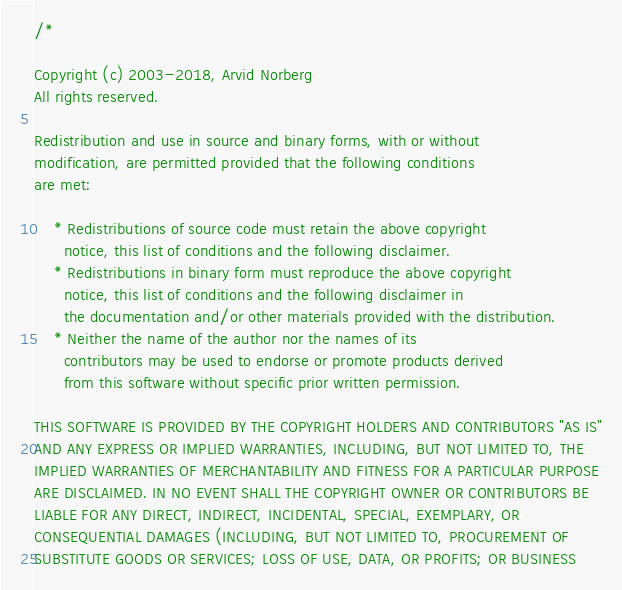<code> <loc_0><loc_0><loc_500><loc_500><_C++_>/*

Copyright (c) 2003-2018, Arvid Norberg
All rights reserved.

Redistribution and use in source and binary forms, with or without
modification, are permitted provided that the following conditions
are met:

    * Redistributions of source code must retain the above copyright
      notice, this list of conditions and the following disclaimer.
    * Redistributions in binary form must reproduce the above copyright
      notice, this list of conditions and the following disclaimer in
      the documentation and/or other materials provided with the distribution.
    * Neither the name of the author nor the names of its
      contributors may be used to endorse or promote products derived
      from this software without specific prior written permission.

THIS SOFTWARE IS PROVIDED BY THE COPYRIGHT HOLDERS AND CONTRIBUTORS "AS IS"
AND ANY EXPRESS OR IMPLIED WARRANTIES, INCLUDING, BUT NOT LIMITED TO, THE
IMPLIED WARRANTIES OF MERCHANTABILITY AND FITNESS FOR A PARTICULAR PURPOSE
ARE DISCLAIMED. IN NO EVENT SHALL THE COPYRIGHT OWNER OR CONTRIBUTORS BE
LIABLE FOR ANY DIRECT, INDIRECT, INCIDENTAL, SPECIAL, EXEMPLARY, OR
CONSEQUENTIAL DAMAGES (INCLUDING, BUT NOT LIMITED TO, PROCUREMENT OF
SUBSTITUTE GOODS OR SERVICES; LOSS OF USE, DATA, OR PROFITS; OR BUSINESS</code> 